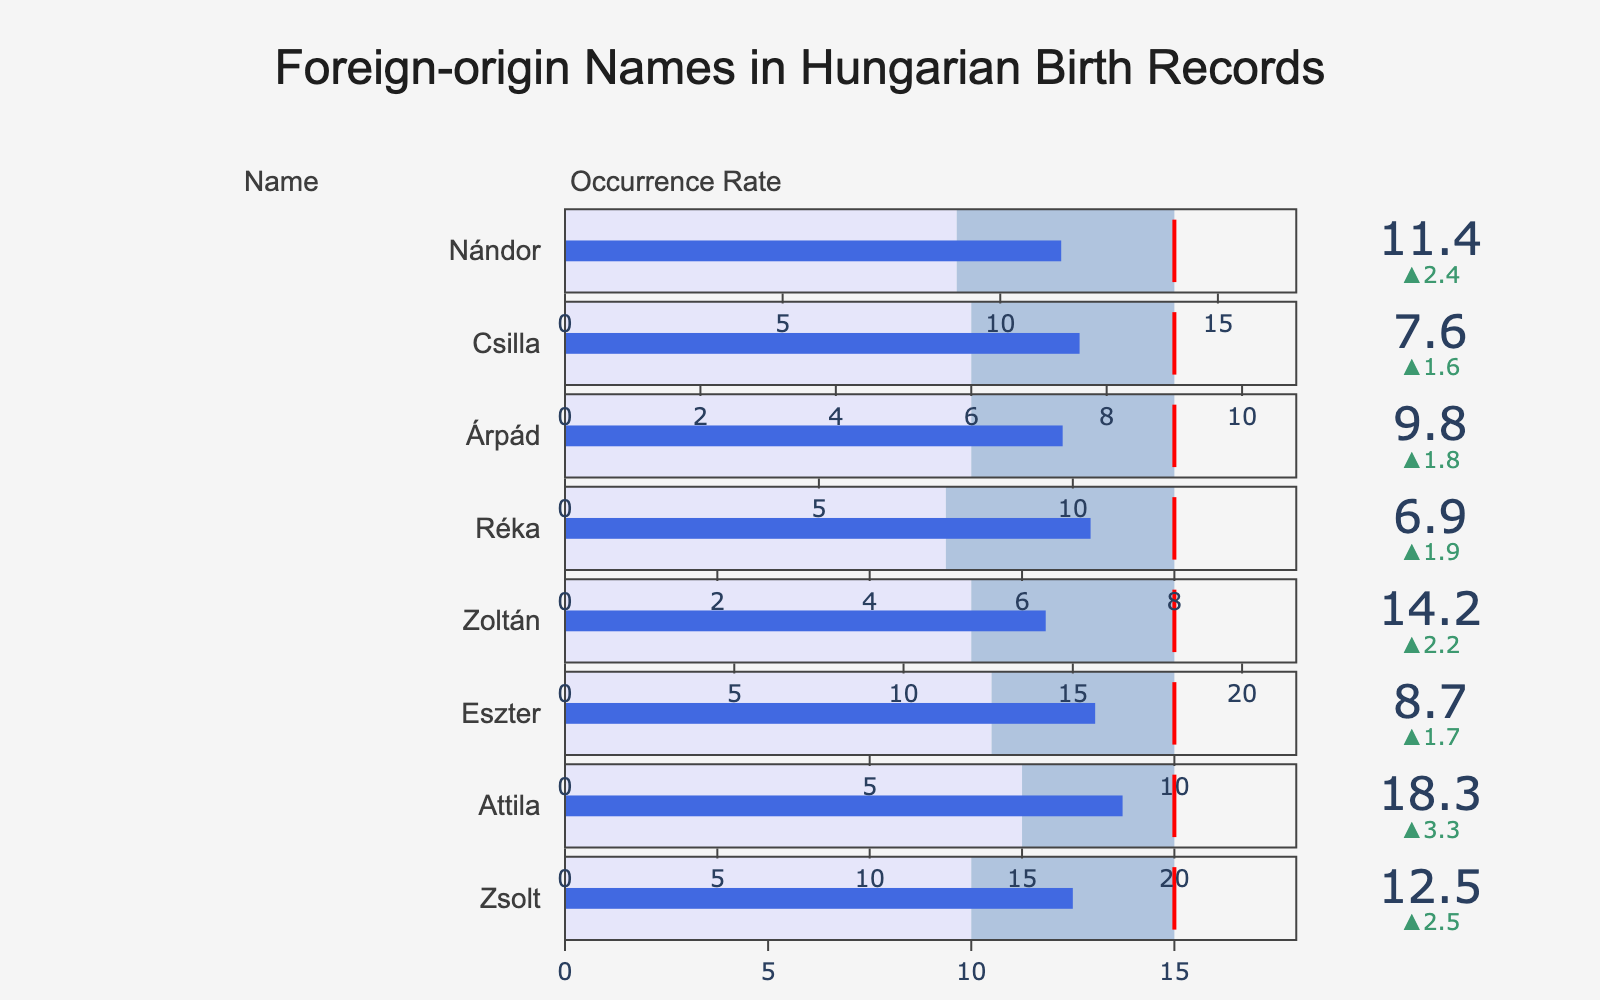What is the title of the chart? The title is directly displayed at the top of the chart. Reading it provides immediate information about the focus of the chart.
Answer: Foreign-origin Names in Hungarian Birth Records How many names are presented in the chart? Count each distinct name listed in the title section of each bullet trace. Each name appears once in the y-axis domain.
Answer: 8 Which name has the highest actual occurrence rate? Look for the bullet trace with the highest "Actual" value. In this case, it corresponds to "Attila" with an actual rate of 18.3.
Answer: Attila What is the difference between the actual and expected occurrence rates for Zsolt? Subtract the expected rate from the actual rate for Zsolt: 12.5 - 10.
Answer: 2.5 Compare the actual occurrence rate of Zoltán and Nándor. Which one is higher? Identify the actual rates for Zoltán (14.2) and Nándor (11.4) and compare them. Zoltán's rate is higher.
Answer: Zoltán Which names have an actual occurrence rate greater than their target rate? Compare the actual rate with the target rate for each name: all actual rates are lower than their targets.
Answer: None What is the target occurrence rate for Réka, and how does it compare to the expected rate? Identify Réka’s target rate (8) and expected rate (5). Compare their numerical values. The target rate is higher than the expected rate.
Answer: Target is 8, which is 3 more than the expected rate Which name's actual occurrence rate falls most short of its target? Calculate the difference between the actual and target rates for each name and identify the largest negative difference. For example, Zoltán’s gap is 14.2 - 18 = -3.8 which is the largest shortfall.
Answer: Zoltán If you sum up the expected occurrence rates of Eszter and Csilla, what do you get? Add the expected rates for Eszter (7) and Csilla (6). Sum them up.
Answer: 13 What color is used to represent the range between the expected and target occurrence rates? Observe the color in the bullet chart segments between the expected and target values. This part is typically colored light blue.
Answer: Light blue 